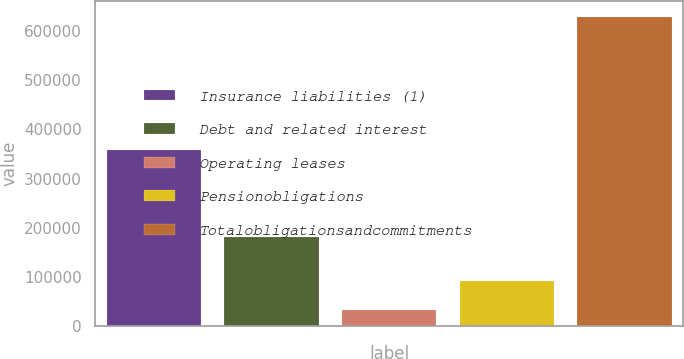Convert chart to OTSL. <chart><loc_0><loc_0><loc_500><loc_500><bar_chart><fcel>Insurance liabilities (1)<fcel>Debt and related interest<fcel>Operating leases<fcel>Pensionobligations<fcel>Totalobligationsandcommitments<nl><fcel>358972<fcel>180563<fcel>32241<fcel>91904.3<fcel>628874<nl></chart> 